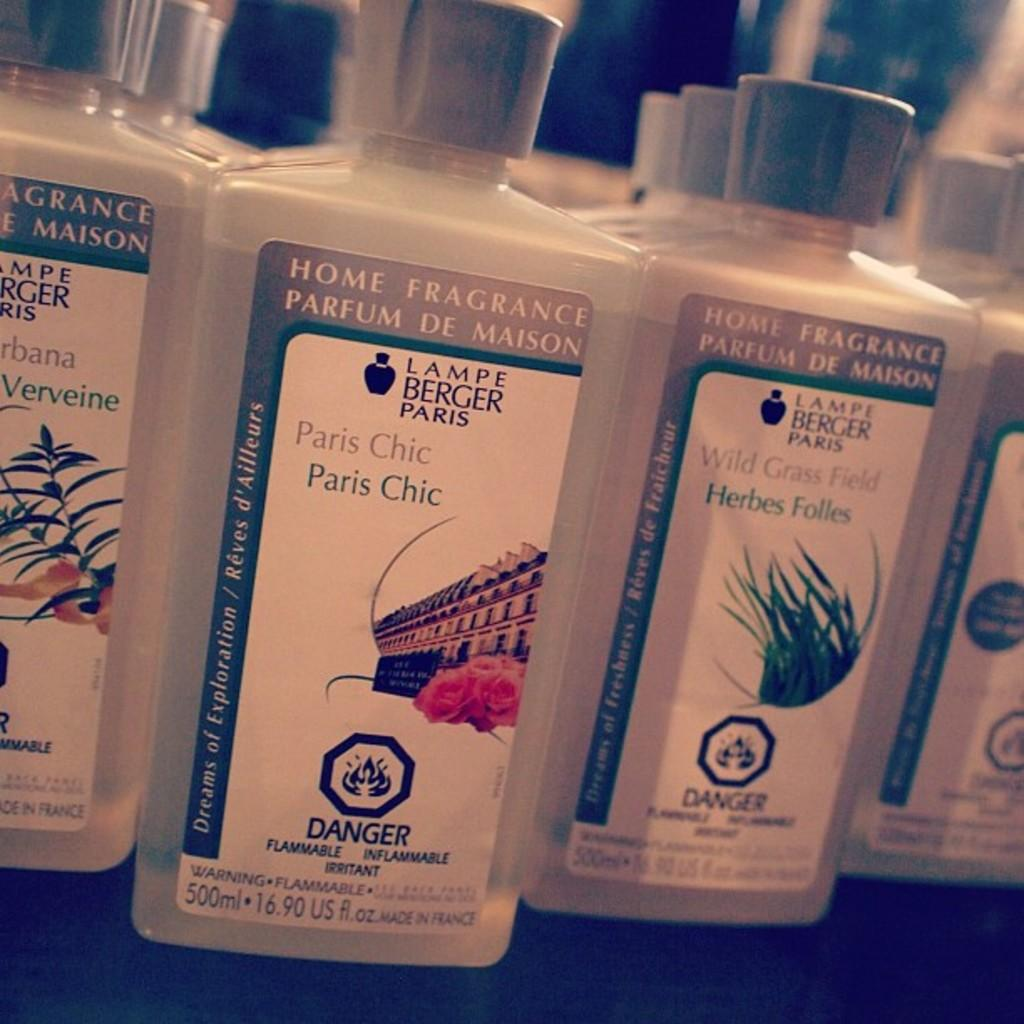<image>
Describe the image concisely. A row of bottles of various scents of Home Fragrance. 